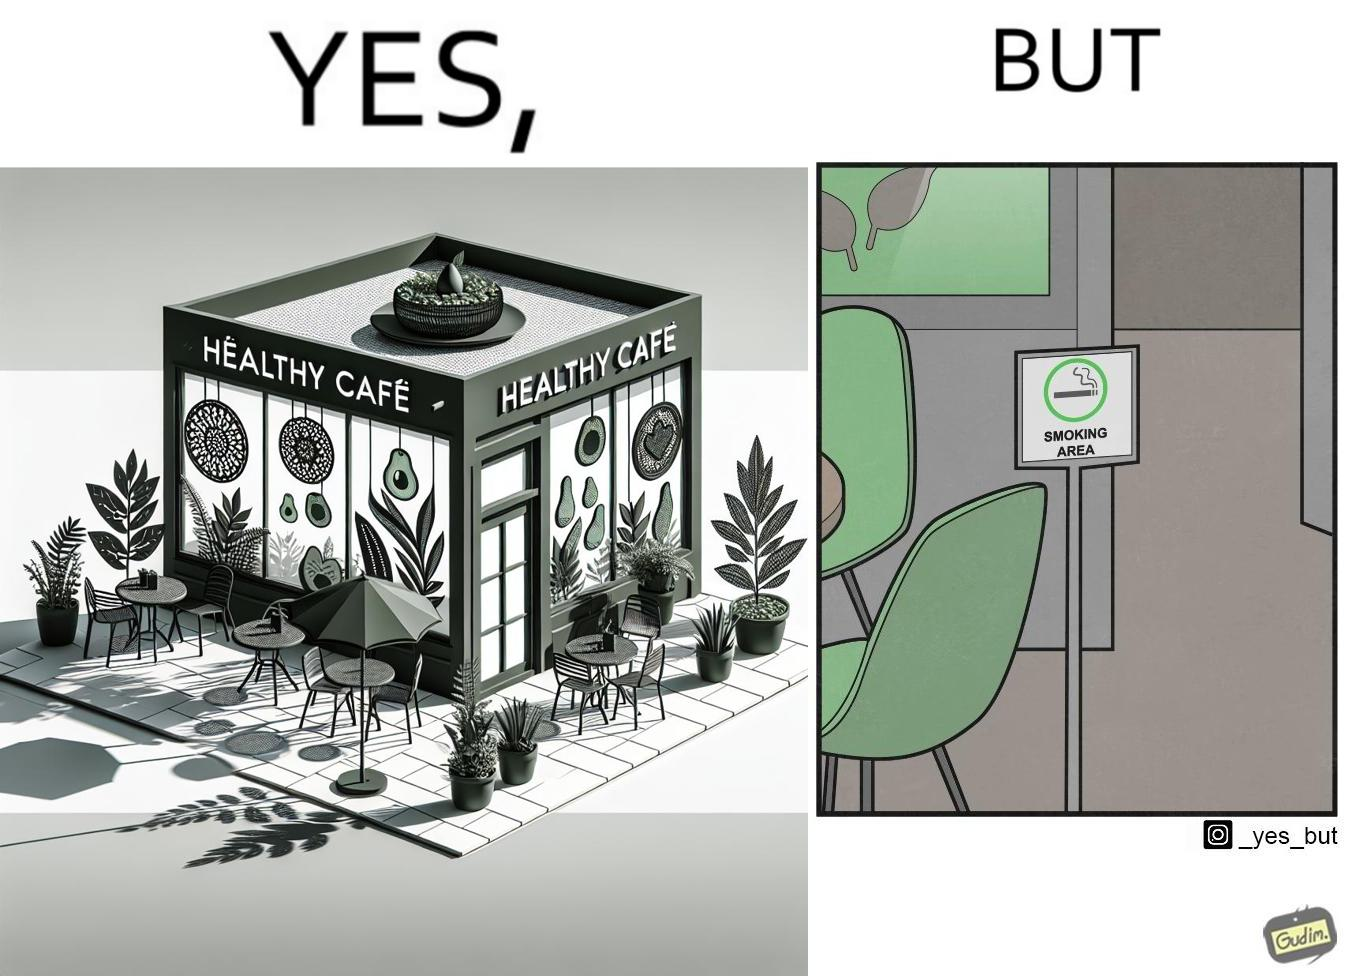Is this image satirical or non-satirical? Yes, this image is satirical. 